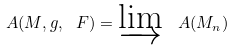<formula> <loc_0><loc_0><loc_500><loc_500>\ A ( M , g , \ F ) = \varinjlim \, \ A ( M _ { n } )</formula> 